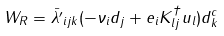Convert formula to latex. <formula><loc_0><loc_0><loc_500><loc_500>W _ { R } = \bar { \lambda ^ { \prime } } _ { i j k } ( - \nu _ { i } d _ { j } + e _ { i } K ^ { \dagger } _ { l j } u _ { l } ) d _ { k } ^ { c }</formula> 